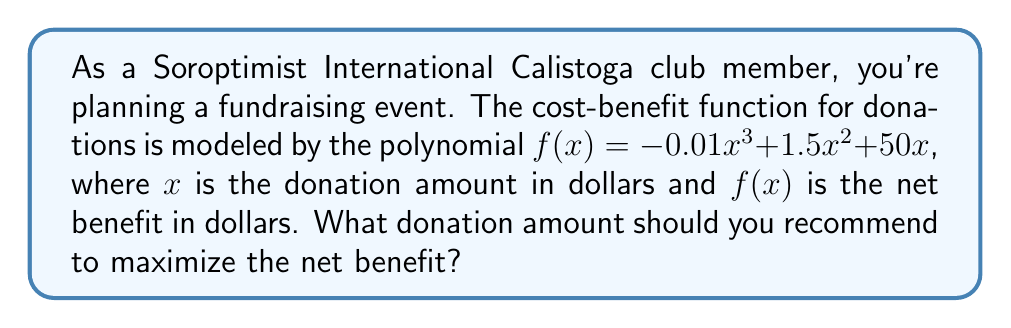Can you solve this math problem? To find the optimal donation amount, we need to find the maximum of the function $f(x) = -0.01x^3 + 1.5x^2 + 50x$. This occurs where the derivative $f'(x) = 0$.

1) Find the derivative:
   $f'(x) = -0.03x^2 + 3x + 50$

2) Set $f'(x) = 0$ and solve:
   $-0.03x^2 + 3x + 50 = 0$

3) This is a quadratic equation. We can solve it using the quadratic formula:
   $x = \frac{-b \pm \sqrt{b^2 - 4ac}}{2a}$
   where $a = -0.03$, $b = 3$, and $c = 50$

4) Substituting these values:
   $x = \frac{-3 \pm \sqrt{3^2 - 4(-0.03)(50)}}{2(-0.03)}$

5) Simplifying:
   $x = \frac{-3 \pm \sqrt{9 + 6}}{-0.06} = \frac{-3 \pm \sqrt{15}}{-0.06}$

6) This gives us two solutions:
   $x_1 \approx 66.67$ and $x_2 \approx 33.33$

7) To determine which solution gives the maximum, we can check the second derivative:
   $f''(x) = -0.06x + 3$

8) At $x = 66.67$, $f''(66.67) < 0$, indicating a maximum.
   At $x = 33.33$, $f''(33.33) > 0$, indicating a minimum.

Therefore, the maximum net benefit occurs at approximately $66.67.
Answer: $66.67 